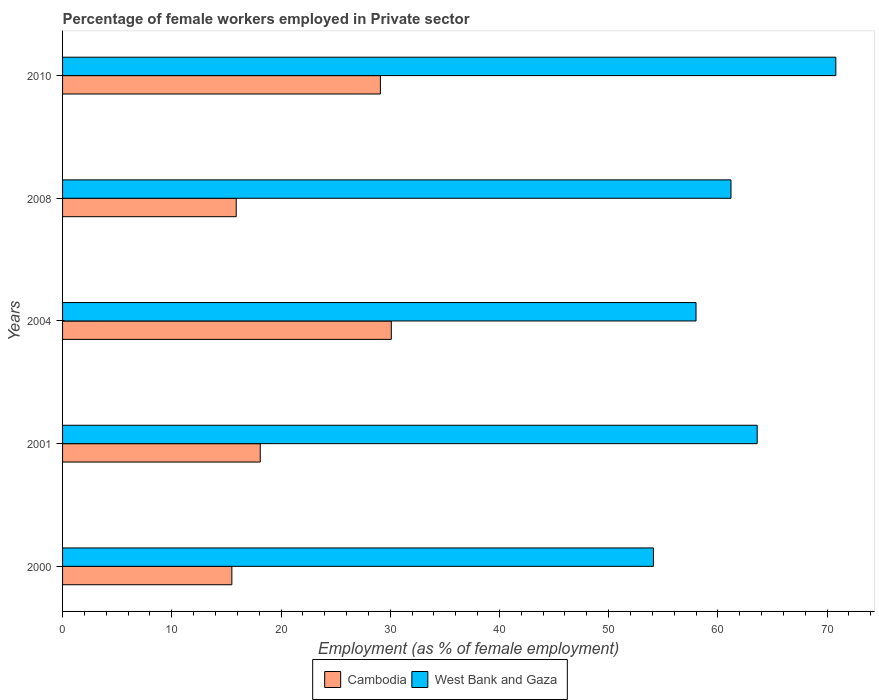What is the label of the 5th group of bars from the top?
Your answer should be compact. 2000. In how many cases, is the number of bars for a given year not equal to the number of legend labels?
Ensure brevity in your answer.  0. What is the percentage of females employed in Private sector in West Bank and Gaza in 2001?
Your response must be concise. 63.6. Across all years, what is the maximum percentage of females employed in Private sector in West Bank and Gaza?
Keep it short and to the point. 70.8. Across all years, what is the minimum percentage of females employed in Private sector in Cambodia?
Provide a succinct answer. 15.5. In which year was the percentage of females employed in Private sector in Cambodia maximum?
Your answer should be very brief. 2004. In which year was the percentage of females employed in Private sector in West Bank and Gaza minimum?
Your response must be concise. 2000. What is the total percentage of females employed in Private sector in Cambodia in the graph?
Your answer should be very brief. 108.7. What is the difference between the percentage of females employed in Private sector in West Bank and Gaza in 2001 and that in 2010?
Your response must be concise. -7.2. What is the difference between the percentage of females employed in Private sector in West Bank and Gaza in 2000 and the percentage of females employed in Private sector in Cambodia in 2001?
Make the answer very short. 36. What is the average percentage of females employed in Private sector in West Bank and Gaza per year?
Provide a succinct answer. 61.54. In the year 2001, what is the difference between the percentage of females employed in Private sector in Cambodia and percentage of females employed in Private sector in West Bank and Gaza?
Ensure brevity in your answer.  -45.5. In how many years, is the percentage of females employed in Private sector in Cambodia greater than 16 %?
Offer a very short reply. 3. What is the ratio of the percentage of females employed in Private sector in Cambodia in 2001 to that in 2008?
Provide a short and direct response. 1.14. Is the percentage of females employed in Private sector in West Bank and Gaza in 2001 less than that in 2010?
Your response must be concise. Yes. Is the difference between the percentage of females employed in Private sector in Cambodia in 2001 and 2004 greater than the difference between the percentage of females employed in Private sector in West Bank and Gaza in 2001 and 2004?
Your response must be concise. No. What is the difference between the highest and the lowest percentage of females employed in Private sector in Cambodia?
Give a very brief answer. 14.6. In how many years, is the percentage of females employed in Private sector in Cambodia greater than the average percentage of females employed in Private sector in Cambodia taken over all years?
Make the answer very short. 2. Is the sum of the percentage of females employed in Private sector in Cambodia in 2008 and 2010 greater than the maximum percentage of females employed in Private sector in West Bank and Gaza across all years?
Offer a very short reply. No. What does the 2nd bar from the top in 2010 represents?
Ensure brevity in your answer.  Cambodia. What does the 2nd bar from the bottom in 2001 represents?
Provide a succinct answer. West Bank and Gaza. How many years are there in the graph?
Make the answer very short. 5. Are the values on the major ticks of X-axis written in scientific E-notation?
Offer a very short reply. No. Does the graph contain any zero values?
Offer a very short reply. No. Does the graph contain grids?
Provide a succinct answer. No. Where does the legend appear in the graph?
Your answer should be compact. Bottom center. What is the title of the graph?
Provide a short and direct response. Percentage of female workers employed in Private sector. What is the label or title of the X-axis?
Your answer should be compact. Employment (as % of female employment). What is the Employment (as % of female employment) of Cambodia in 2000?
Your answer should be compact. 15.5. What is the Employment (as % of female employment) in West Bank and Gaza in 2000?
Your answer should be very brief. 54.1. What is the Employment (as % of female employment) of Cambodia in 2001?
Offer a terse response. 18.1. What is the Employment (as % of female employment) of West Bank and Gaza in 2001?
Provide a short and direct response. 63.6. What is the Employment (as % of female employment) in Cambodia in 2004?
Offer a terse response. 30.1. What is the Employment (as % of female employment) of West Bank and Gaza in 2004?
Ensure brevity in your answer.  58. What is the Employment (as % of female employment) in Cambodia in 2008?
Give a very brief answer. 15.9. What is the Employment (as % of female employment) in West Bank and Gaza in 2008?
Your answer should be very brief. 61.2. What is the Employment (as % of female employment) in Cambodia in 2010?
Keep it short and to the point. 29.1. What is the Employment (as % of female employment) of West Bank and Gaza in 2010?
Your answer should be very brief. 70.8. Across all years, what is the maximum Employment (as % of female employment) in Cambodia?
Provide a succinct answer. 30.1. Across all years, what is the maximum Employment (as % of female employment) in West Bank and Gaza?
Make the answer very short. 70.8. Across all years, what is the minimum Employment (as % of female employment) of West Bank and Gaza?
Make the answer very short. 54.1. What is the total Employment (as % of female employment) in Cambodia in the graph?
Keep it short and to the point. 108.7. What is the total Employment (as % of female employment) in West Bank and Gaza in the graph?
Offer a very short reply. 307.7. What is the difference between the Employment (as % of female employment) of Cambodia in 2000 and that in 2001?
Provide a succinct answer. -2.6. What is the difference between the Employment (as % of female employment) in Cambodia in 2000 and that in 2004?
Keep it short and to the point. -14.6. What is the difference between the Employment (as % of female employment) in Cambodia in 2000 and that in 2008?
Your response must be concise. -0.4. What is the difference between the Employment (as % of female employment) of Cambodia in 2000 and that in 2010?
Provide a short and direct response. -13.6. What is the difference between the Employment (as % of female employment) in West Bank and Gaza in 2000 and that in 2010?
Give a very brief answer. -16.7. What is the difference between the Employment (as % of female employment) in West Bank and Gaza in 2001 and that in 2004?
Give a very brief answer. 5.6. What is the difference between the Employment (as % of female employment) of Cambodia in 2001 and that in 2008?
Offer a terse response. 2.2. What is the difference between the Employment (as % of female employment) in West Bank and Gaza in 2001 and that in 2008?
Keep it short and to the point. 2.4. What is the difference between the Employment (as % of female employment) in Cambodia in 2001 and that in 2010?
Your answer should be compact. -11. What is the difference between the Employment (as % of female employment) in West Bank and Gaza in 2001 and that in 2010?
Your answer should be very brief. -7.2. What is the difference between the Employment (as % of female employment) of Cambodia in 2004 and that in 2008?
Offer a very short reply. 14.2. What is the difference between the Employment (as % of female employment) of Cambodia in 2004 and that in 2010?
Ensure brevity in your answer.  1. What is the difference between the Employment (as % of female employment) of West Bank and Gaza in 2004 and that in 2010?
Keep it short and to the point. -12.8. What is the difference between the Employment (as % of female employment) of Cambodia in 2008 and that in 2010?
Your response must be concise. -13.2. What is the difference between the Employment (as % of female employment) of West Bank and Gaza in 2008 and that in 2010?
Provide a succinct answer. -9.6. What is the difference between the Employment (as % of female employment) of Cambodia in 2000 and the Employment (as % of female employment) of West Bank and Gaza in 2001?
Make the answer very short. -48.1. What is the difference between the Employment (as % of female employment) of Cambodia in 2000 and the Employment (as % of female employment) of West Bank and Gaza in 2004?
Your answer should be very brief. -42.5. What is the difference between the Employment (as % of female employment) in Cambodia in 2000 and the Employment (as % of female employment) in West Bank and Gaza in 2008?
Make the answer very short. -45.7. What is the difference between the Employment (as % of female employment) of Cambodia in 2000 and the Employment (as % of female employment) of West Bank and Gaza in 2010?
Provide a short and direct response. -55.3. What is the difference between the Employment (as % of female employment) of Cambodia in 2001 and the Employment (as % of female employment) of West Bank and Gaza in 2004?
Keep it short and to the point. -39.9. What is the difference between the Employment (as % of female employment) in Cambodia in 2001 and the Employment (as % of female employment) in West Bank and Gaza in 2008?
Keep it short and to the point. -43.1. What is the difference between the Employment (as % of female employment) of Cambodia in 2001 and the Employment (as % of female employment) of West Bank and Gaza in 2010?
Ensure brevity in your answer.  -52.7. What is the difference between the Employment (as % of female employment) of Cambodia in 2004 and the Employment (as % of female employment) of West Bank and Gaza in 2008?
Your answer should be compact. -31.1. What is the difference between the Employment (as % of female employment) of Cambodia in 2004 and the Employment (as % of female employment) of West Bank and Gaza in 2010?
Give a very brief answer. -40.7. What is the difference between the Employment (as % of female employment) of Cambodia in 2008 and the Employment (as % of female employment) of West Bank and Gaza in 2010?
Keep it short and to the point. -54.9. What is the average Employment (as % of female employment) in Cambodia per year?
Offer a terse response. 21.74. What is the average Employment (as % of female employment) of West Bank and Gaza per year?
Your answer should be compact. 61.54. In the year 2000, what is the difference between the Employment (as % of female employment) in Cambodia and Employment (as % of female employment) in West Bank and Gaza?
Your answer should be compact. -38.6. In the year 2001, what is the difference between the Employment (as % of female employment) of Cambodia and Employment (as % of female employment) of West Bank and Gaza?
Provide a succinct answer. -45.5. In the year 2004, what is the difference between the Employment (as % of female employment) in Cambodia and Employment (as % of female employment) in West Bank and Gaza?
Keep it short and to the point. -27.9. In the year 2008, what is the difference between the Employment (as % of female employment) in Cambodia and Employment (as % of female employment) in West Bank and Gaza?
Your answer should be compact. -45.3. In the year 2010, what is the difference between the Employment (as % of female employment) of Cambodia and Employment (as % of female employment) of West Bank and Gaza?
Offer a very short reply. -41.7. What is the ratio of the Employment (as % of female employment) of Cambodia in 2000 to that in 2001?
Your answer should be compact. 0.86. What is the ratio of the Employment (as % of female employment) of West Bank and Gaza in 2000 to that in 2001?
Make the answer very short. 0.85. What is the ratio of the Employment (as % of female employment) in Cambodia in 2000 to that in 2004?
Ensure brevity in your answer.  0.52. What is the ratio of the Employment (as % of female employment) of West Bank and Gaza in 2000 to that in 2004?
Your response must be concise. 0.93. What is the ratio of the Employment (as % of female employment) of Cambodia in 2000 to that in 2008?
Offer a terse response. 0.97. What is the ratio of the Employment (as % of female employment) in West Bank and Gaza in 2000 to that in 2008?
Give a very brief answer. 0.88. What is the ratio of the Employment (as % of female employment) of Cambodia in 2000 to that in 2010?
Your answer should be very brief. 0.53. What is the ratio of the Employment (as % of female employment) of West Bank and Gaza in 2000 to that in 2010?
Your answer should be very brief. 0.76. What is the ratio of the Employment (as % of female employment) of Cambodia in 2001 to that in 2004?
Your response must be concise. 0.6. What is the ratio of the Employment (as % of female employment) in West Bank and Gaza in 2001 to that in 2004?
Provide a succinct answer. 1.1. What is the ratio of the Employment (as % of female employment) in Cambodia in 2001 to that in 2008?
Keep it short and to the point. 1.14. What is the ratio of the Employment (as % of female employment) of West Bank and Gaza in 2001 to that in 2008?
Your answer should be compact. 1.04. What is the ratio of the Employment (as % of female employment) in Cambodia in 2001 to that in 2010?
Ensure brevity in your answer.  0.62. What is the ratio of the Employment (as % of female employment) of West Bank and Gaza in 2001 to that in 2010?
Ensure brevity in your answer.  0.9. What is the ratio of the Employment (as % of female employment) of Cambodia in 2004 to that in 2008?
Your response must be concise. 1.89. What is the ratio of the Employment (as % of female employment) in West Bank and Gaza in 2004 to that in 2008?
Your response must be concise. 0.95. What is the ratio of the Employment (as % of female employment) of Cambodia in 2004 to that in 2010?
Ensure brevity in your answer.  1.03. What is the ratio of the Employment (as % of female employment) in West Bank and Gaza in 2004 to that in 2010?
Your answer should be very brief. 0.82. What is the ratio of the Employment (as % of female employment) in Cambodia in 2008 to that in 2010?
Make the answer very short. 0.55. What is the ratio of the Employment (as % of female employment) in West Bank and Gaza in 2008 to that in 2010?
Offer a very short reply. 0.86. What is the difference between the highest and the second highest Employment (as % of female employment) in West Bank and Gaza?
Provide a succinct answer. 7.2. What is the difference between the highest and the lowest Employment (as % of female employment) in Cambodia?
Keep it short and to the point. 14.6. 